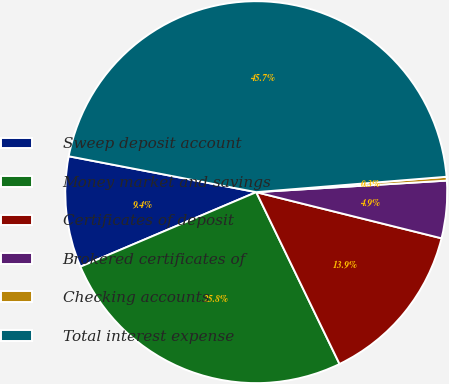<chart> <loc_0><loc_0><loc_500><loc_500><pie_chart><fcel>Sweep deposit account<fcel>Money market and savings<fcel>Certificates of deposit<fcel>Brokered certificates of<fcel>Checking accounts<fcel>Total interest expense<nl><fcel>9.39%<fcel>25.8%<fcel>13.93%<fcel>4.85%<fcel>0.32%<fcel>45.7%<nl></chart> 